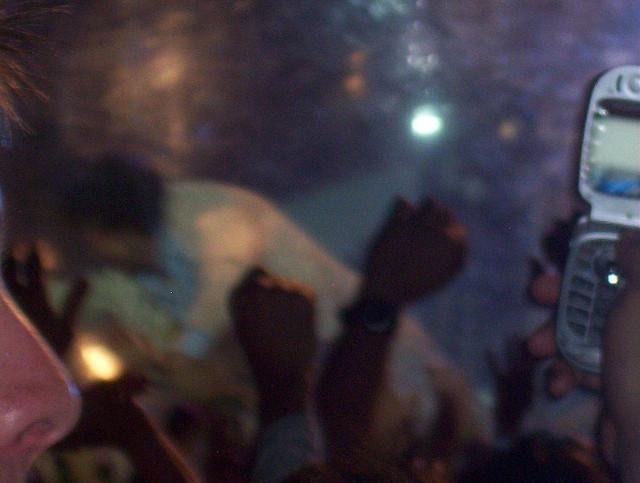Where is this?
Keep it brief. Concert. What corner is the little screen on?
Short answer required. Top right. Does this photo look out of focus?
Short answer required. Yes. What is the man taking a picture of?
Be succinct. Concert. What color is the woman's hair?
Quick response, please. Brown. Is she packing for vacation?
Concise answer only. No. How clear is the picture?
Keep it brief. Not clear. Is someone holding a cellphone up?
Answer briefly. Yes. 